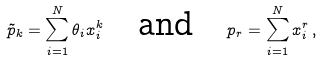<formula> <loc_0><loc_0><loc_500><loc_500>\tilde { p } _ { k } = \sum _ { i = 1 } ^ { N } \theta _ { i } x _ { i } ^ { k } \quad \text {and} \quad p _ { r } = \sum _ { i = 1 } ^ { N } x _ { i } ^ { r } \, ,</formula> 